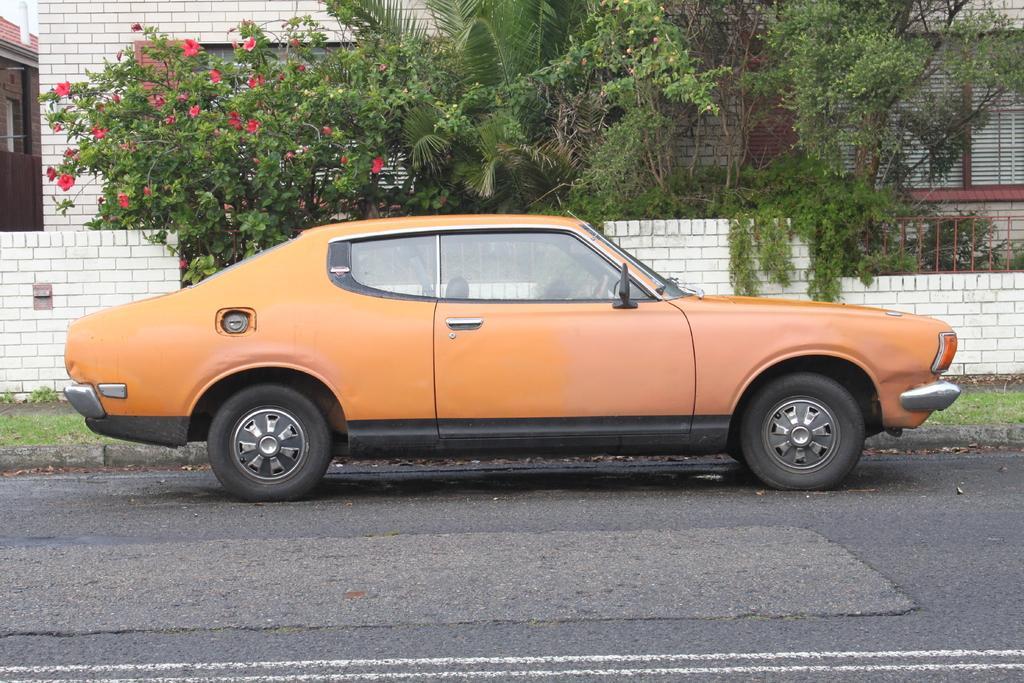In one or two sentences, can you explain what this image depicts? In the picture I can see a car on the road. In the background I can see trees, plants, the grass, fence wall and a building. 